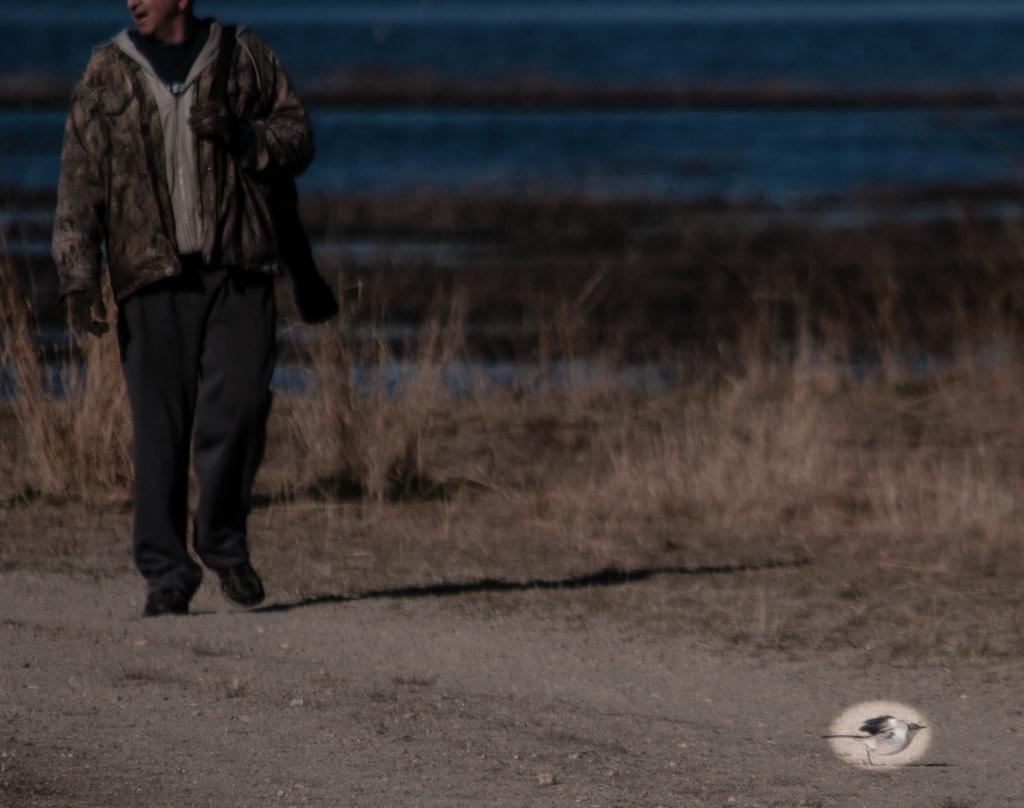Describe this image in one or two sentences. On the left side of the image we can see a person walking. In the background there is grass. 